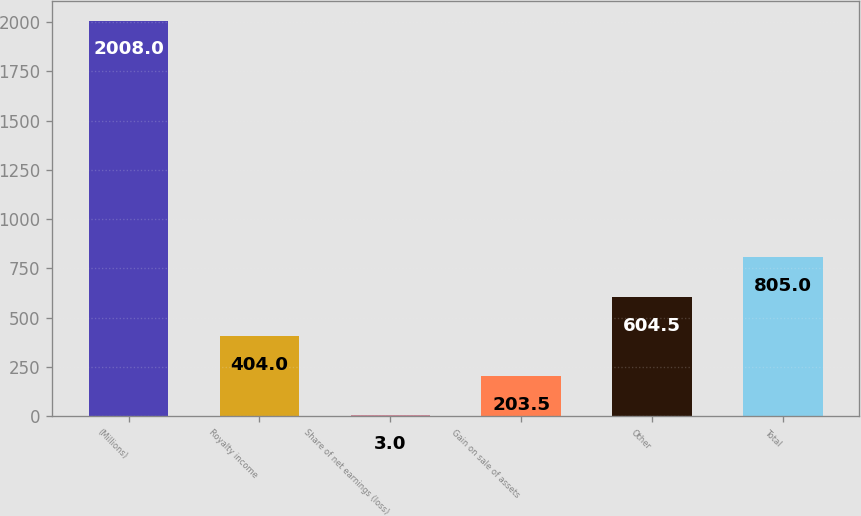Convert chart to OTSL. <chart><loc_0><loc_0><loc_500><loc_500><bar_chart><fcel>(Millions)<fcel>Royalty income<fcel>Share of net earnings (loss)<fcel>Gain on sale of assets<fcel>Other<fcel>Total<nl><fcel>2008<fcel>404<fcel>3<fcel>203.5<fcel>604.5<fcel>805<nl></chart> 